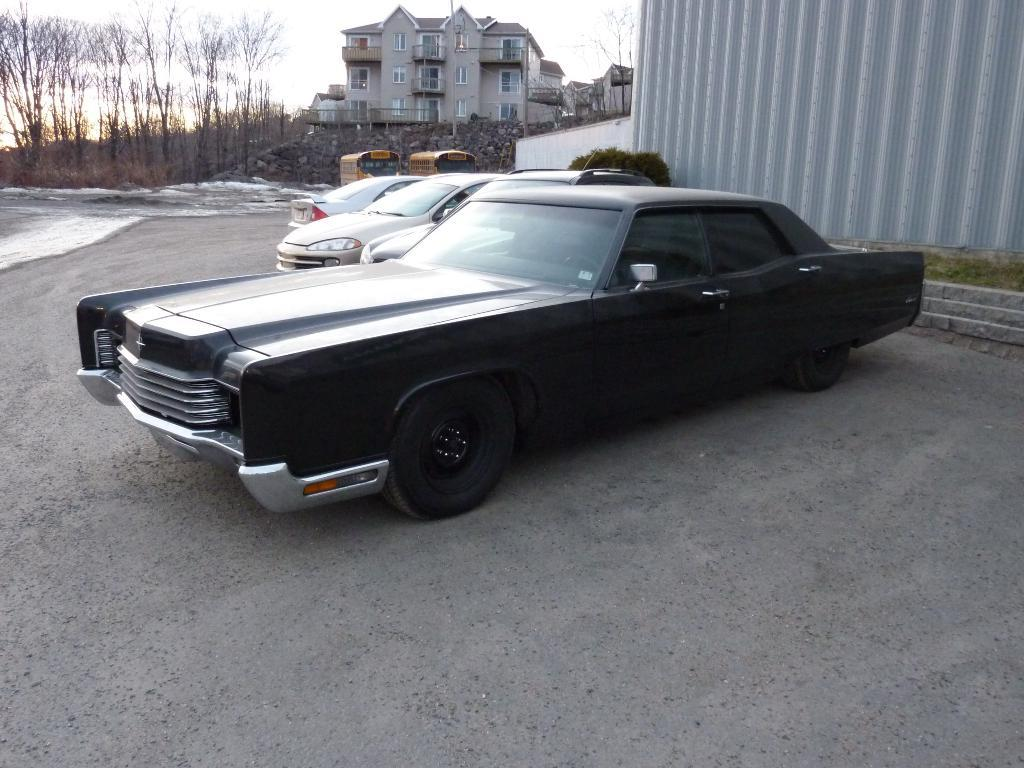What types of objects can be seen in the image? There are vehicles, buildings, windows, trees, and plants in the image. Can you describe the architectural features in the image? There is a wall visible in the image. What might be used for transportation in the image? The vehicles in the image can be used for transportation. What type of hobbies can be seen being practiced in the image? There are no hobbies being practiced in the image; it primarily features vehicles, buildings, windows, trees, and plants. Can you tell me how many quills are visible in the image? There are no quills present in the image. 